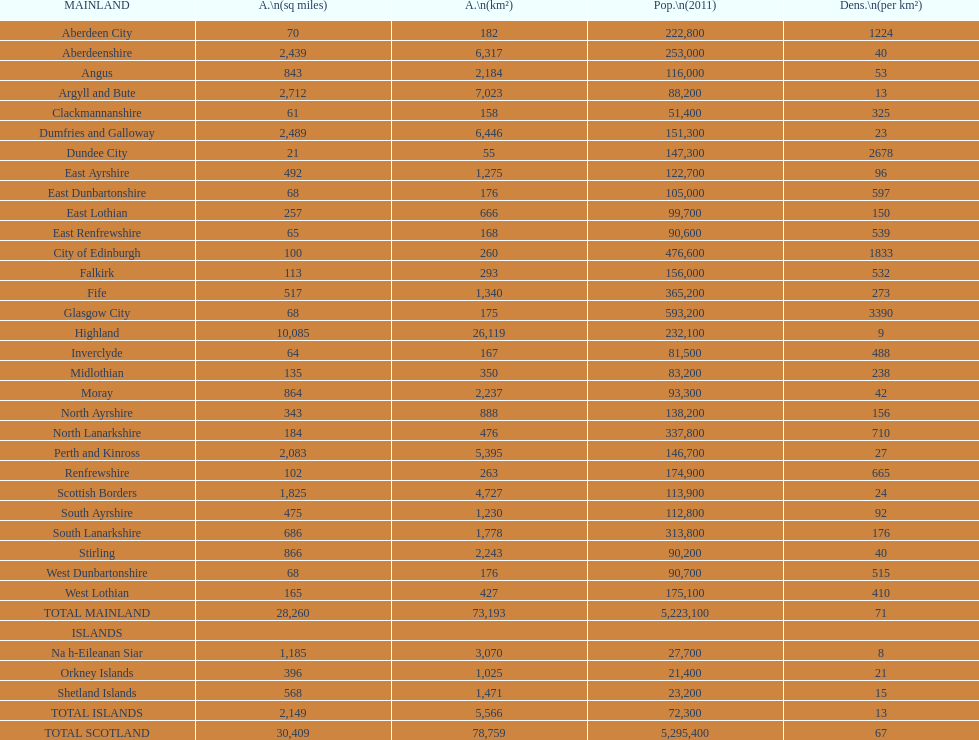What is the difference in square miles from angus and fife? 326. 